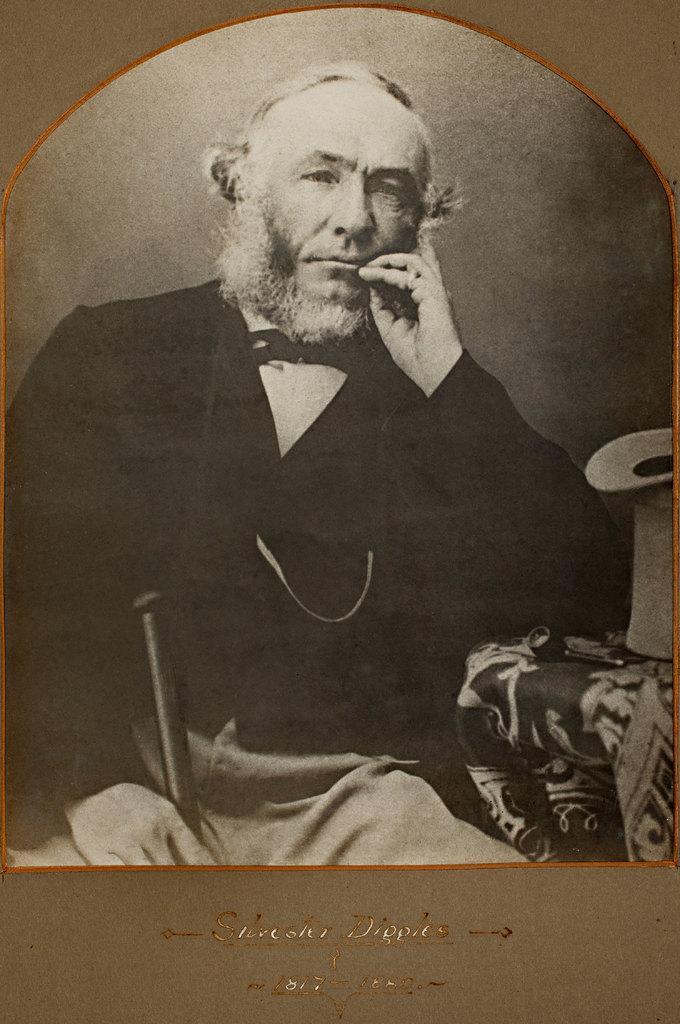Could you give a brief overview of what you see in this image? This is a black and white picture. At the bottom there is text. In the center we can see a person sitting in a couch, he is holding an object. 